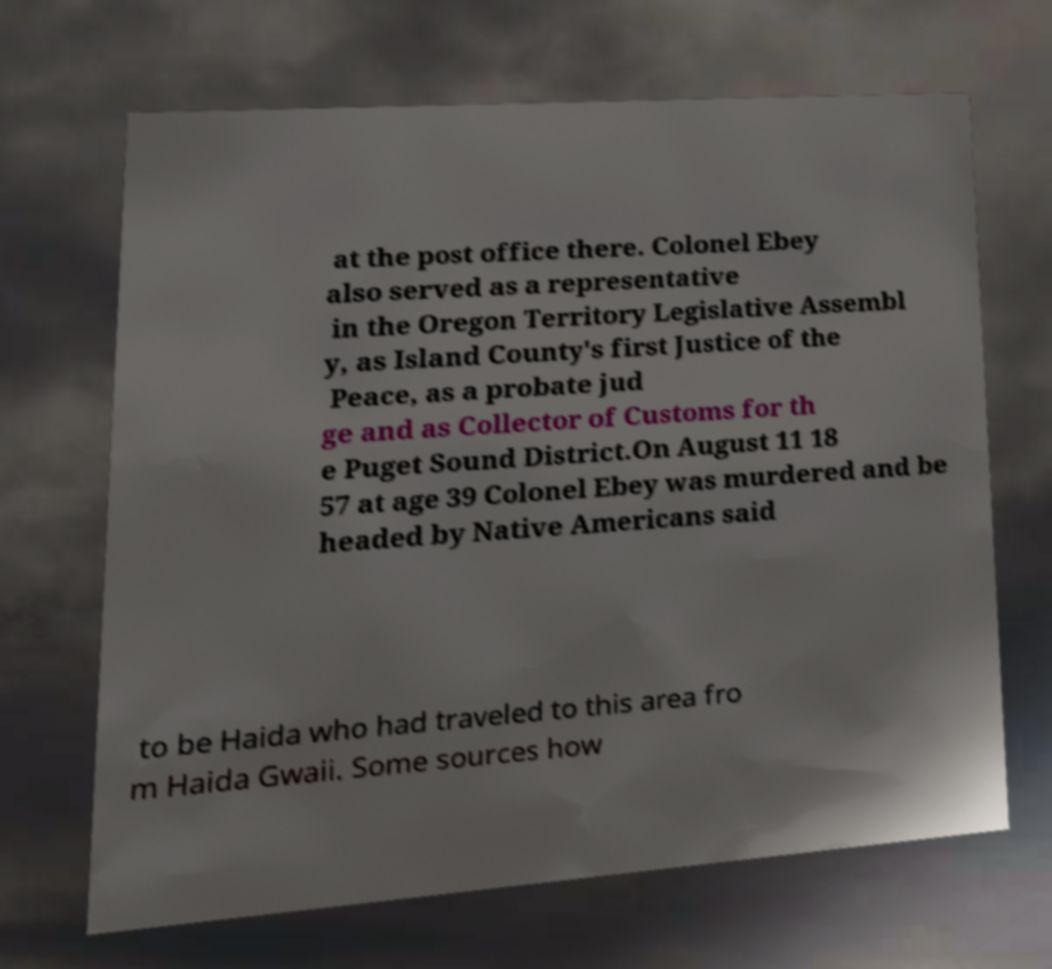Could you extract and type out the text from this image? at the post office there. Colonel Ebey also served as a representative in the Oregon Territory Legislative Assembl y, as Island County's first Justice of the Peace, as a probate jud ge and as Collector of Customs for th e Puget Sound District.On August 11 18 57 at age 39 Colonel Ebey was murdered and be headed by Native Americans said to be Haida who had traveled to this area fro m Haida Gwaii. Some sources how 